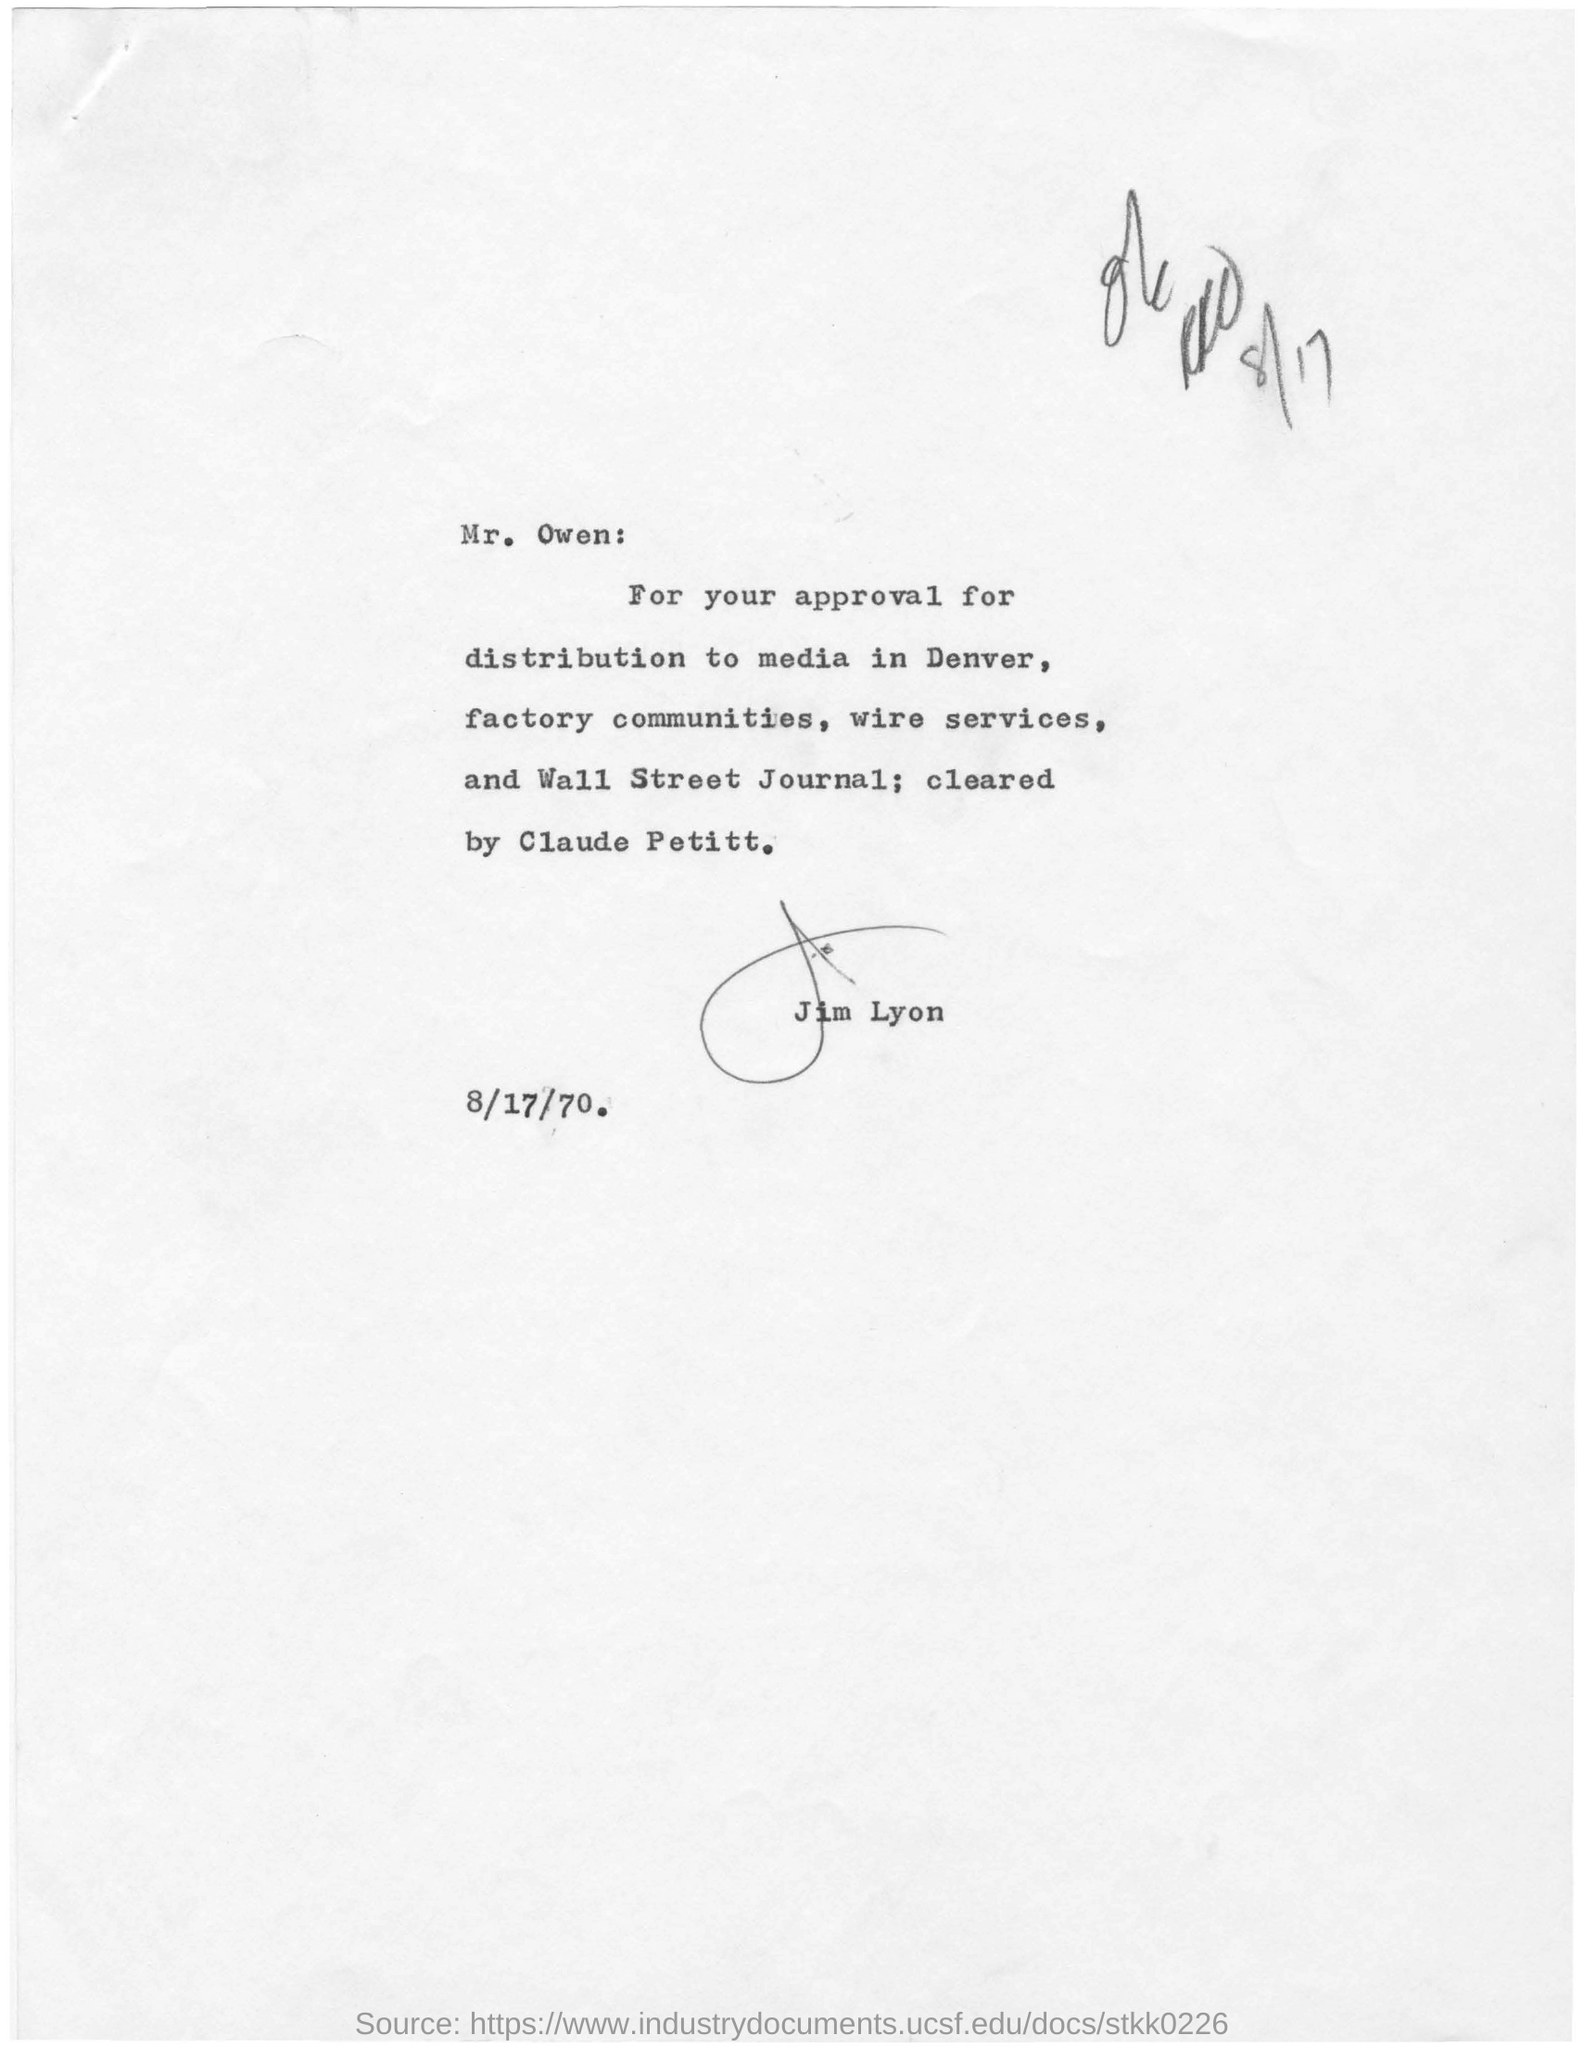Outline some significant characteristics in this image. The date mentioned in the given page is August 17, 1970. The signature at the bottom of the letter was that of Jim Lyon. The letter was written to Mr. Owen. 